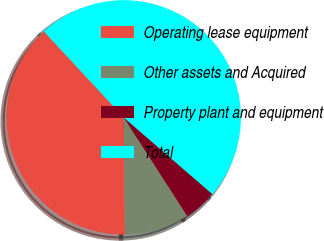Convert chart. <chart><loc_0><loc_0><loc_500><loc_500><pie_chart><fcel>Operating lease equipment<fcel>Other assets and Acquired<fcel>Property plant and equipment<fcel>Total<nl><fcel>38.25%<fcel>8.93%<fcel>4.55%<fcel>48.27%<nl></chart> 